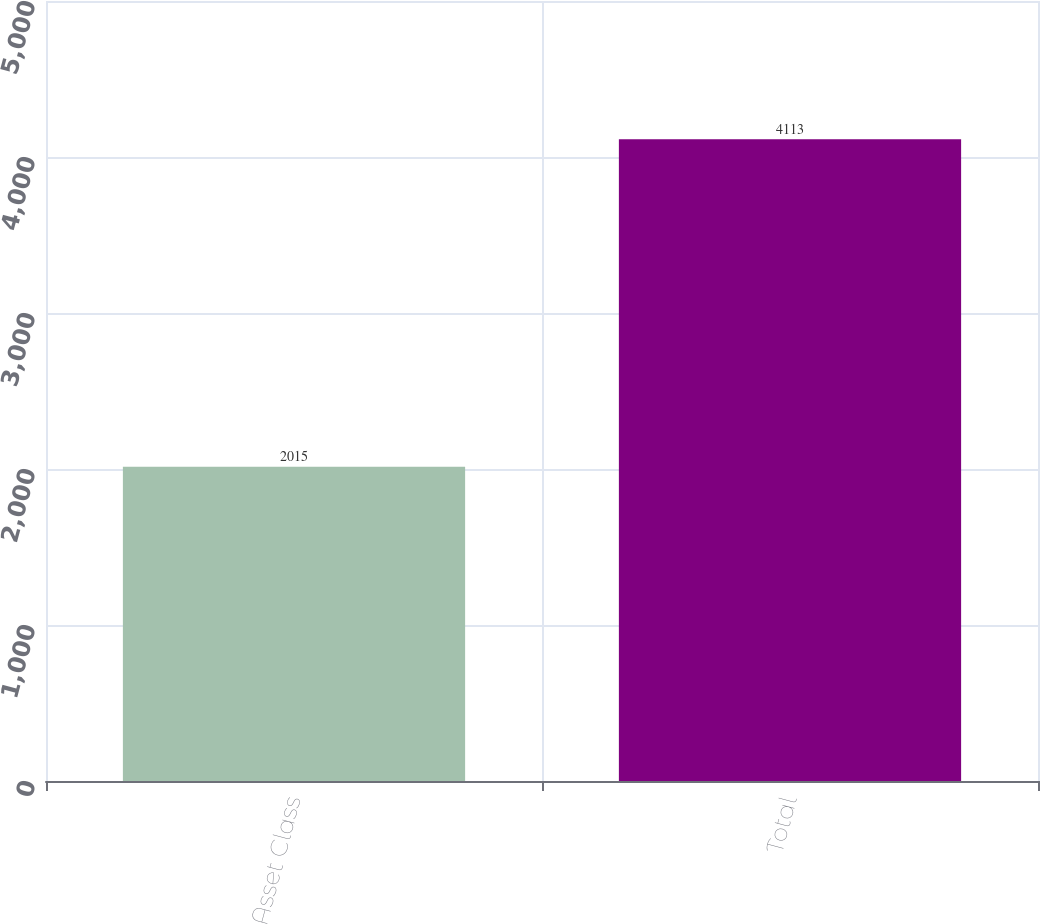Convert chart. <chart><loc_0><loc_0><loc_500><loc_500><bar_chart><fcel>Asset Class<fcel>Total<nl><fcel>2015<fcel>4113<nl></chart> 